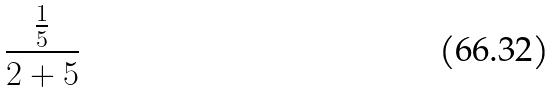Convert formula to latex. <formula><loc_0><loc_0><loc_500><loc_500>\frac { \frac { 1 } { 5 } } { 2 + 5 }</formula> 